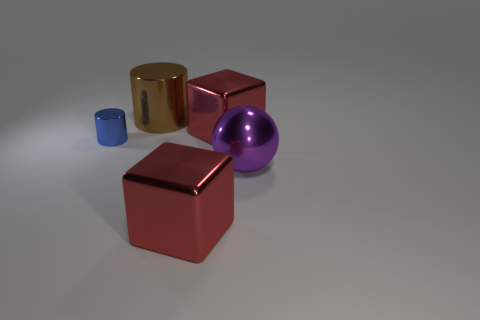Are any big purple matte cylinders visible?
Your answer should be compact. No. There is a metal thing that is right of the brown object and behind the purple sphere; what is its size?
Give a very brief answer. Large. The big purple shiny thing has what shape?
Offer a terse response. Sphere. There is a red shiny cube behind the blue cylinder; is there a red cube in front of it?
Your answer should be very brief. Yes. There is a cylinder that is the same size as the purple object; what is its material?
Provide a short and direct response. Metal. Is there a red metallic object that has the same size as the ball?
Give a very brief answer. Yes. Does the big red cube in front of the large ball have the same material as the large brown cylinder?
Provide a short and direct response. Yes. What is the shape of the brown metallic thing that is the same size as the purple metallic thing?
Your answer should be compact. Cylinder. What number of large metallic balls have the same color as the tiny cylinder?
Keep it short and to the point. 0. Are there fewer big cubes that are behind the small blue metallic cylinder than large shiny things behind the shiny ball?
Keep it short and to the point. Yes. 